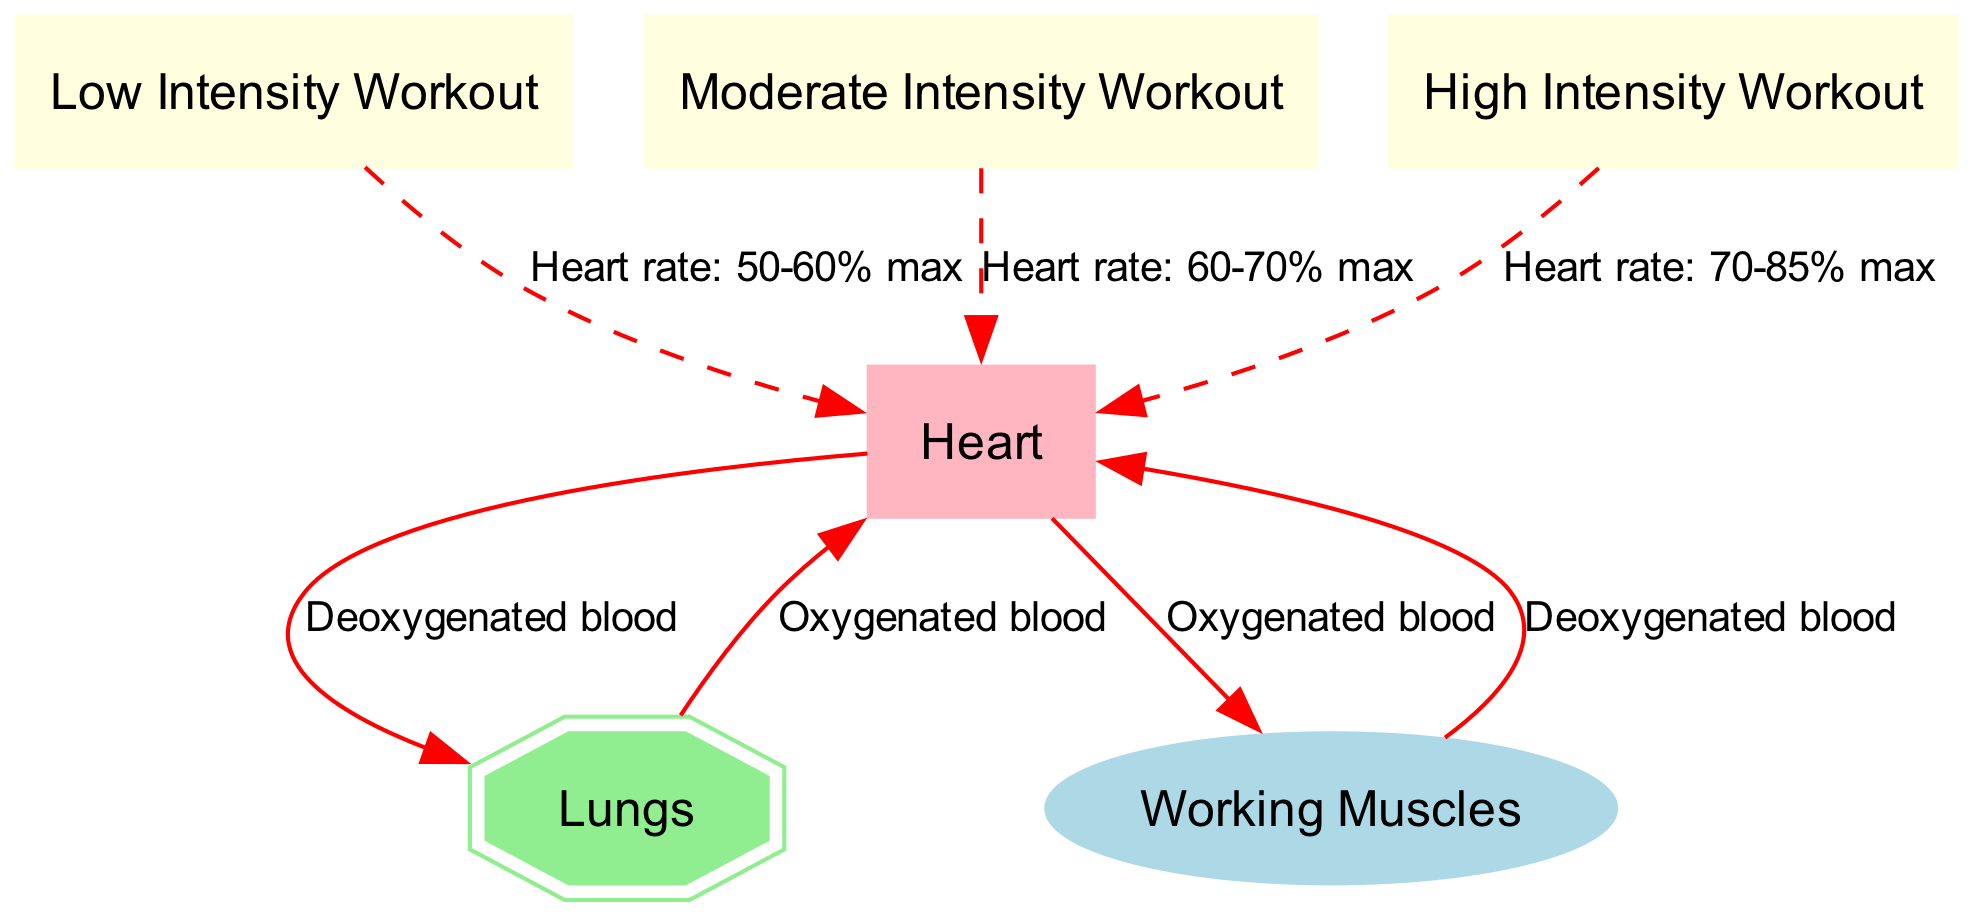What are the nodes in this diagram? The nodes represent important components of the cardiovascular system and workout intensities: Heart, Lungs, Working Muscles, Low Intensity Workout, Moderate Intensity Workout, and High Intensity Workout.
Answer: Heart, Lungs, Working Muscles, Low Intensity Workout, Moderate Intensity Workout, High Intensity Workout How many edges are there in total? The edges represent the relationships and blood flow between the nodes. There are a total of 7 edges connecting these nodes.
Answer: 7 What type of blood does the heart send to the lungs? The edge indicates that the heart sends deoxygenated blood to the lungs.
Answer: Deoxygenated blood What is the heart rate during moderate intensity workout? The edge from moderate intensity to the heart specifies the heart rate during this workout as 60-70% max.
Answer: 60-70% max Which node has a dashed edge coming from high intensity workout? The high intensity workout connects to the heart with a dashed line, indicating the heart rate in that context.
Answer: Heart Which component receives oxygenated blood from the lungs? The connection shows that the heart receives oxygenated blood from the lungs.
Answer: Heart When engaging in high intensity workouts, what is the heart rate range? The edge from high intensity workout to the heart shows that the heart rate during this workout is between 70-85% max.
Answer: 70-85% max What is the flow of deoxygenated blood from muscles? The flow starts from Working Muscles going back to the heart, indicating that it returns deoxygenated blood.
Answer: To the heart What component sends oxygenated blood to the working muscles? The edge indicates that the heart sends oxygenated blood to the working muscles.
Answer: Working Muscles 